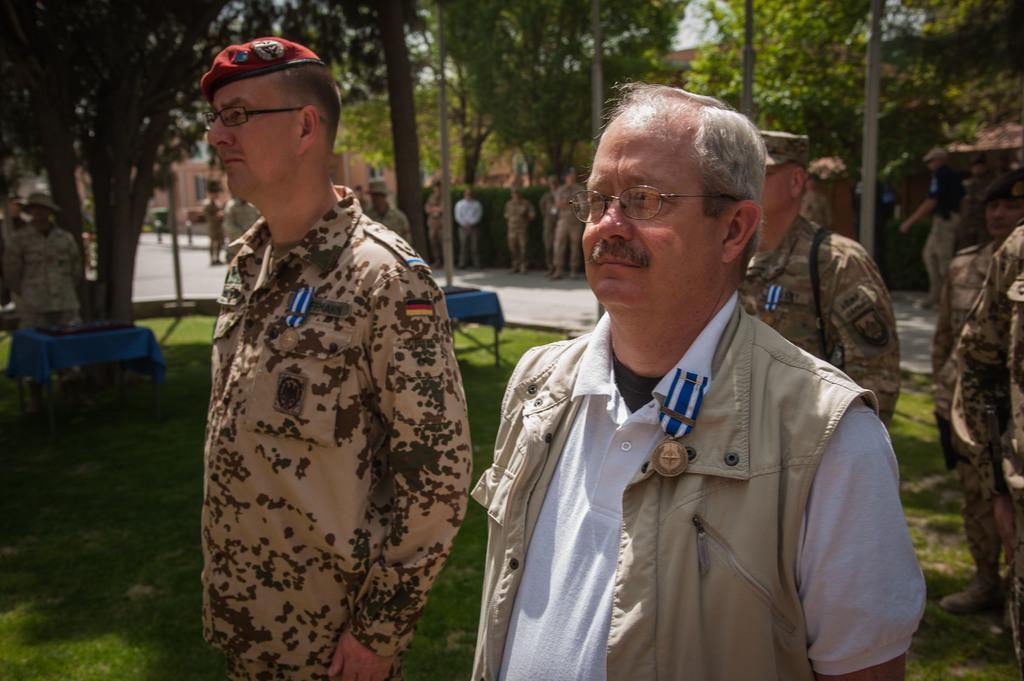How would you summarize this image in a sentence or two? In the image we can see there are lot of people who are standing on the ground. The ground is covered with grass. At the back people are standing on the footpath and there are lot of trees in the area. 